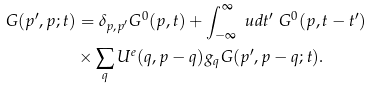<formula> <loc_0><loc_0><loc_500><loc_500>G ( p ^ { \prime } , p ; t ) & = \delta _ { p , p ^ { \prime } } G ^ { 0 } ( p , t ) + \int ^ { \infty } _ { - \infty } \ u d t ^ { \prime } \ G ^ { 0 } ( p , t - t ^ { \prime } ) \\ & \times \sum _ { q } U ^ { e } ( q , p - q ) g _ { q } G ( p ^ { \prime } , p - q ; t ) .</formula> 